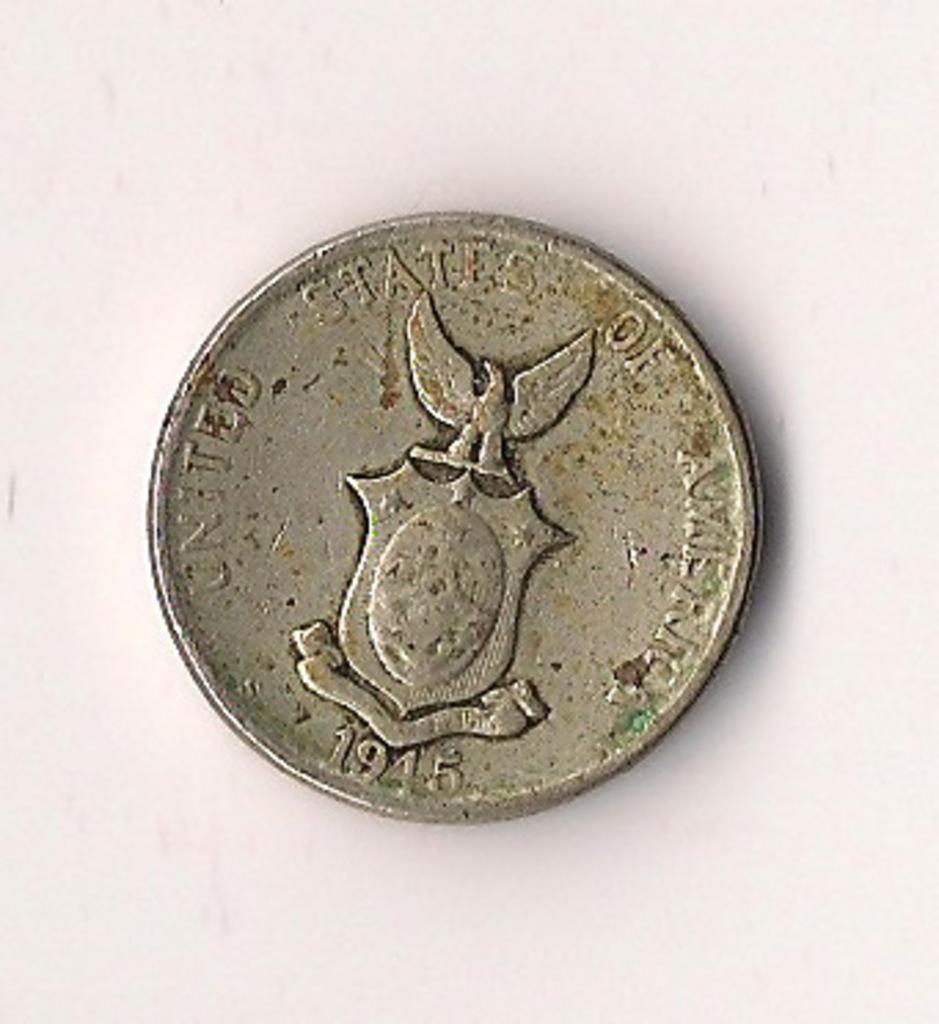Provide a one-sentence caption for the provided image. The United States issued limited edition World War 2 victory coins. 